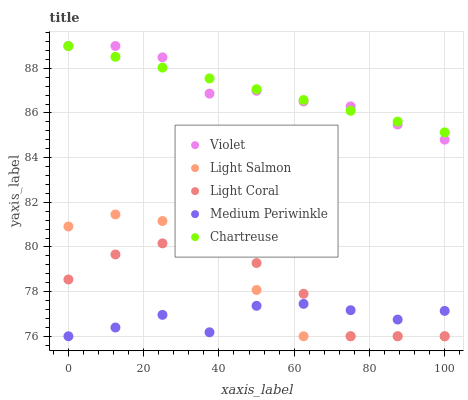Does Medium Periwinkle have the minimum area under the curve?
Answer yes or no. Yes. Does Violet have the maximum area under the curve?
Answer yes or no. Yes. Does Light Salmon have the minimum area under the curve?
Answer yes or no. No. Does Light Salmon have the maximum area under the curve?
Answer yes or no. No. Is Chartreuse the smoothest?
Answer yes or no. Yes. Is Medium Periwinkle the roughest?
Answer yes or no. Yes. Is Light Salmon the smoothest?
Answer yes or no. No. Is Light Salmon the roughest?
Answer yes or no. No. Does Light Coral have the lowest value?
Answer yes or no. Yes. Does Chartreuse have the lowest value?
Answer yes or no. No. Does Violet have the highest value?
Answer yes or no. Yes. Does Light Salmon have the highest value?
Answer yes or no. No. Is Light Coral less than Violet?
Answer yes or no. Yes. Is Chartreuse greater than Light Salmon?
Answer yes or no. Yes. Does Chartreuse intersect Violet?
Answer yes or no. Yes. Is Chartreuse less than Violet?
Answer yes or no. No. Is Chartreuse greater than Violet?
Answer yes or no. No. Does Light Coral intersect Violet?
Answer yes or no. No. 